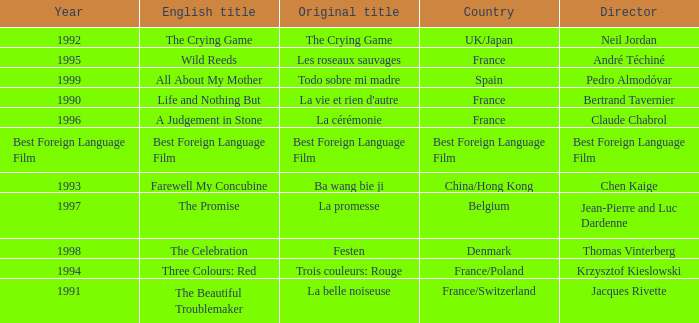Which Country is listed for the Director Thomas Vinterberg? Denmark. 